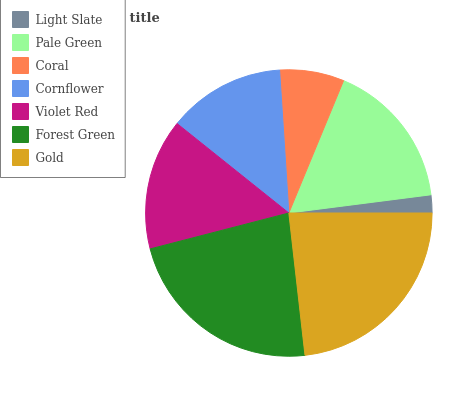Is Light Slate the minimum?
Answer yes or no. Yes. Is Gold the maximum?
Answer yes or no. Yes. Is Pale Green the minimum?
Answer yes or no. No. Is Pale Green the maximum?
Answer yes or no. No. Is Pale Green greater than Light Slate?
Answer yes or no. Yes. Is Light Slate less than Pale Green?
Answer yes or no. Yes. Is Light Slate greater than Pale Green?
Answer yes or no. No. Is Pale Green less than Light Slate?
Answer yes or no. No. Is Violet Red the high median?
Answer yes or no. Yes. Is Violet Red the low median?
Answer yes or no. Yes. Is Cornflower the high median?
Answer yes or no. No. Is Coral the low median?
Answer yes or no. No. 